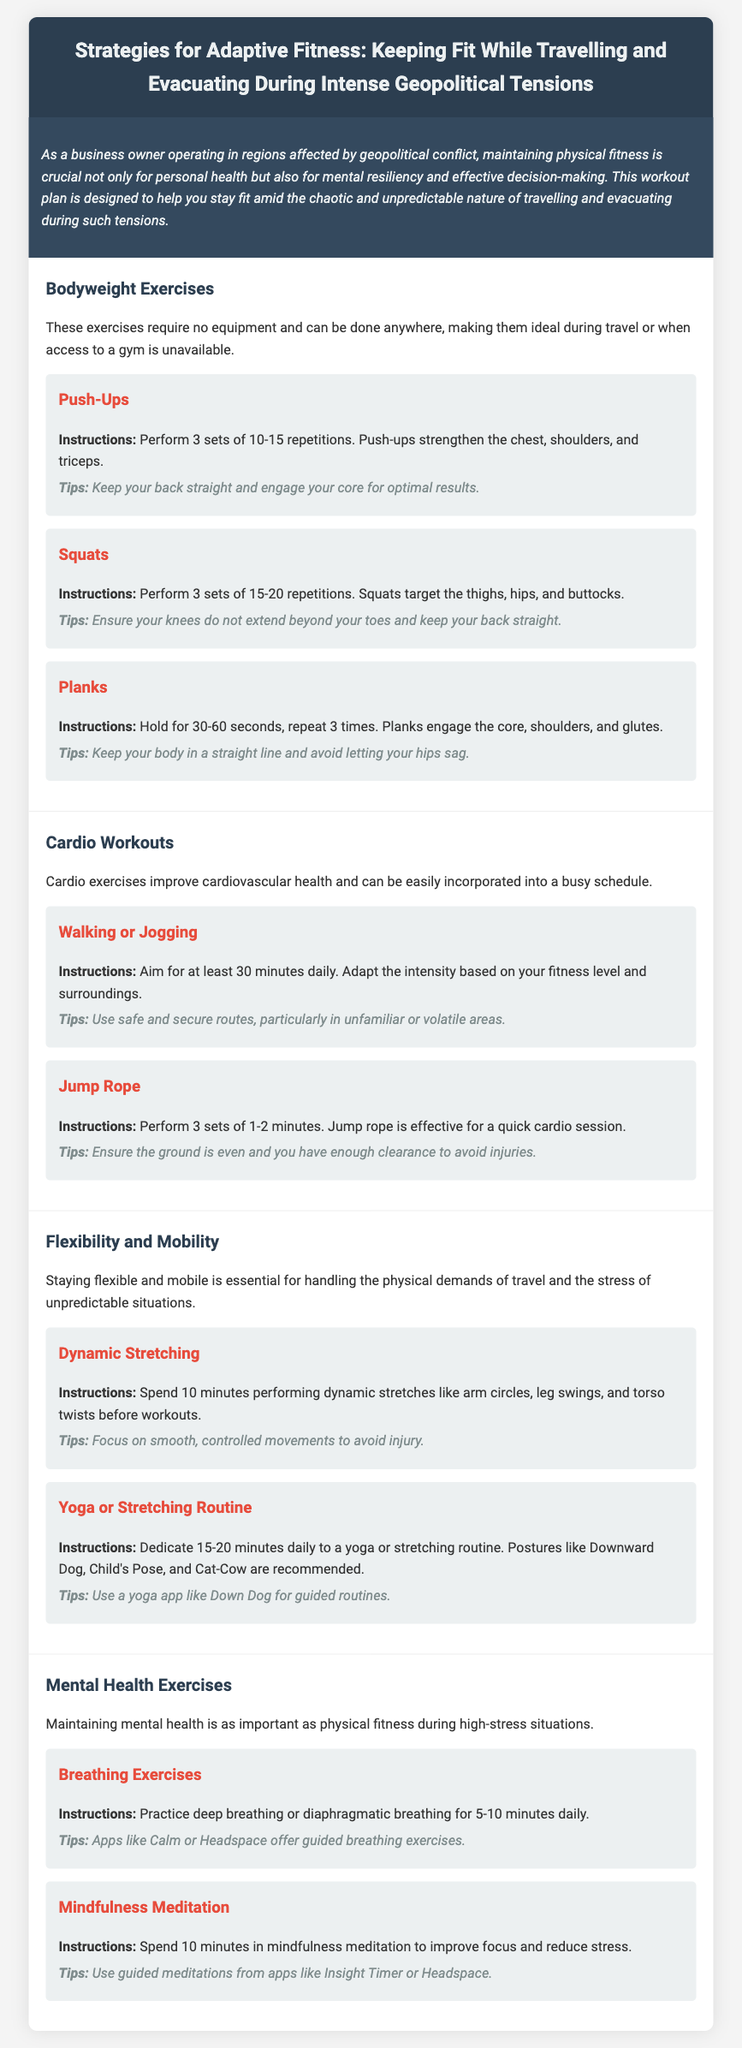what is the title of the document? The title is explicitly stated at the top of the document as the main heading.
Answer: Strategies for Adaptive Fitness: Keeping Fit While Travelling and Evacuating During Intense Geopolitical Tensions how many bodyweight exercises are listed? The document provides a count of the bodyweight exercises under the "Bodyweight Exercises" section.
Answer: 3 what duration is recommended for mindfulness meditation? The recommended duration for mindfulness meditation is provided in the "Mental Health Exercises" section of the document.
Answer: 10 minutes what is one tip for performing push-ups? The document includes specific tips for exercises, including push-ups, which can be found in the respective section.
Answer: Keep your back straight and engage your core for optimal results how many sets of squats should be performed? This information is specified under the "Squats" exercise in the "Bodyweight Exercises" section.
Answer: 3 sets what are two recommended yoga poses? The document lists specific yoga poses recommended for the stretching routine under "Flexibility and Mobility."
Answer: Downward Dog, Child's Pose what is the purpose of the introduction section? The introduction provides context and significance regarding the importance of fitness for business owners in conflict regions.
Answer: To highlight the importance of maintaining physical fitness how long should dynamic stretching be performed? The duration for dynamic stretching is specified in the "Flexibility and Mobility" section.
Answer: 10 minutes 